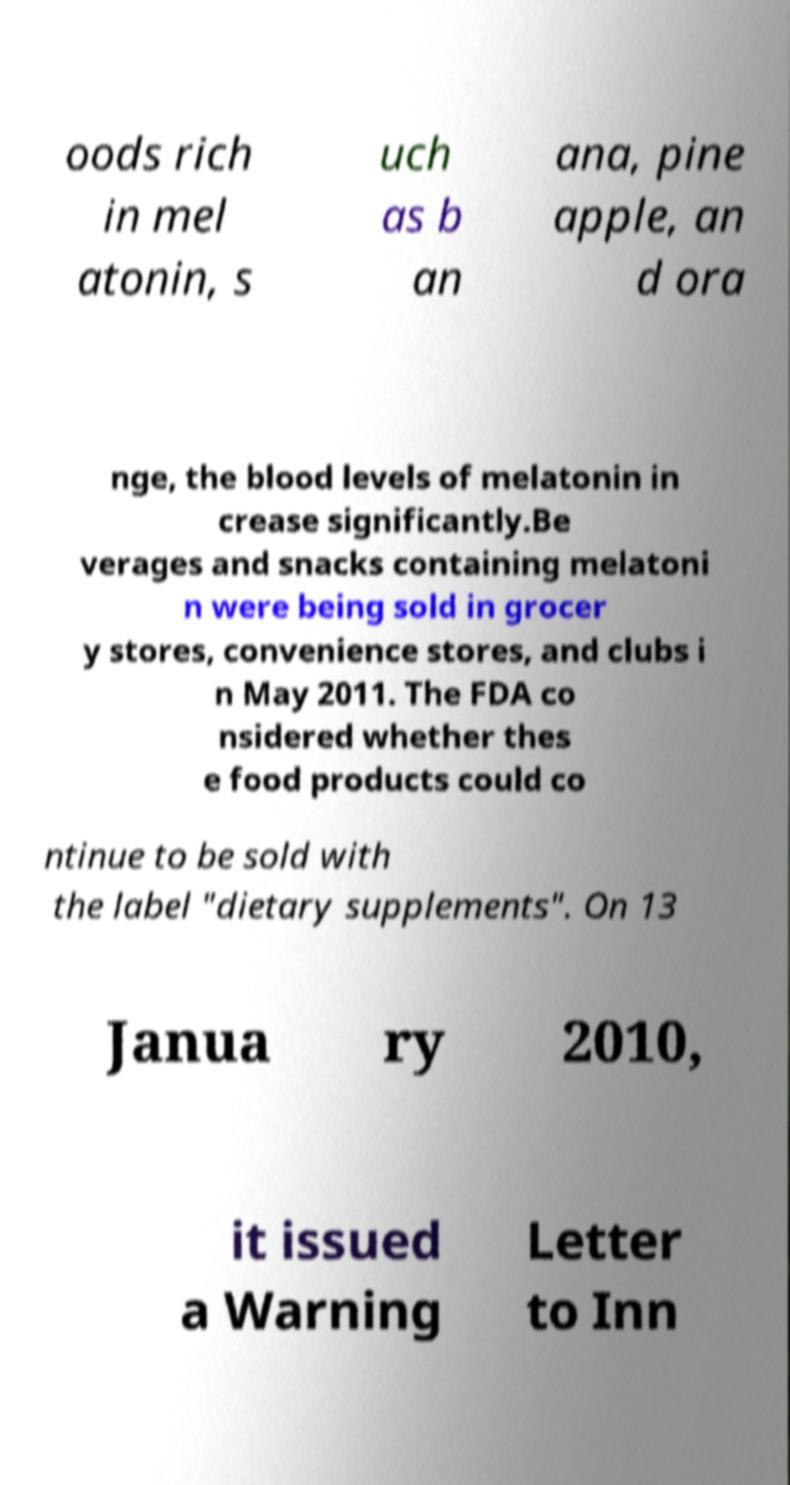There's text embedded in this image that I need extracted. Can you transcribe it verbatim? oods rich in mel atonin, s uch as b an ana, pine apple, an d ora nge, the blood levels of melatonin in crease significantly.Be verages and snacks containing melatoni n were being sold in grocer y stores, convenience stores, and clubs i n May 2011. The FDA co nsidered whether thes e food products could co ntinue to be sold with the label "dietary supplements". On 13 Janua ry 2010, it issued a Warning Letter to Inn 